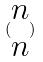Convert formula to latex. <formula><loc_0><loc_0><loc_500><loc_500>( \begin{matrix} n \\ n \end{matrix} )</formula> 